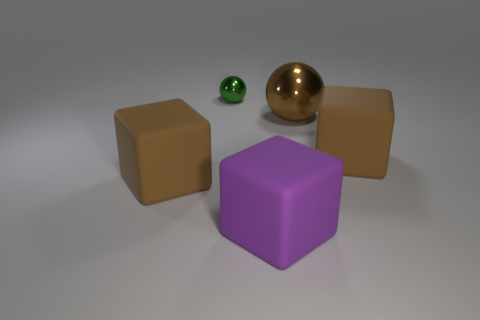Add 1 gray rubber cylinders. How many objects exist? 6 Subtract all blocks. How many objects are left? 2 Subtract 0 yellow spheres. How many objects are left? 5 Subtract all rubber objects. Subtract all big spheres. How many objects are left? 1 Add 4 purple matte things. How many purple matte things are left? 5 Add 3 big brown things. How many big brown things exist? 6 